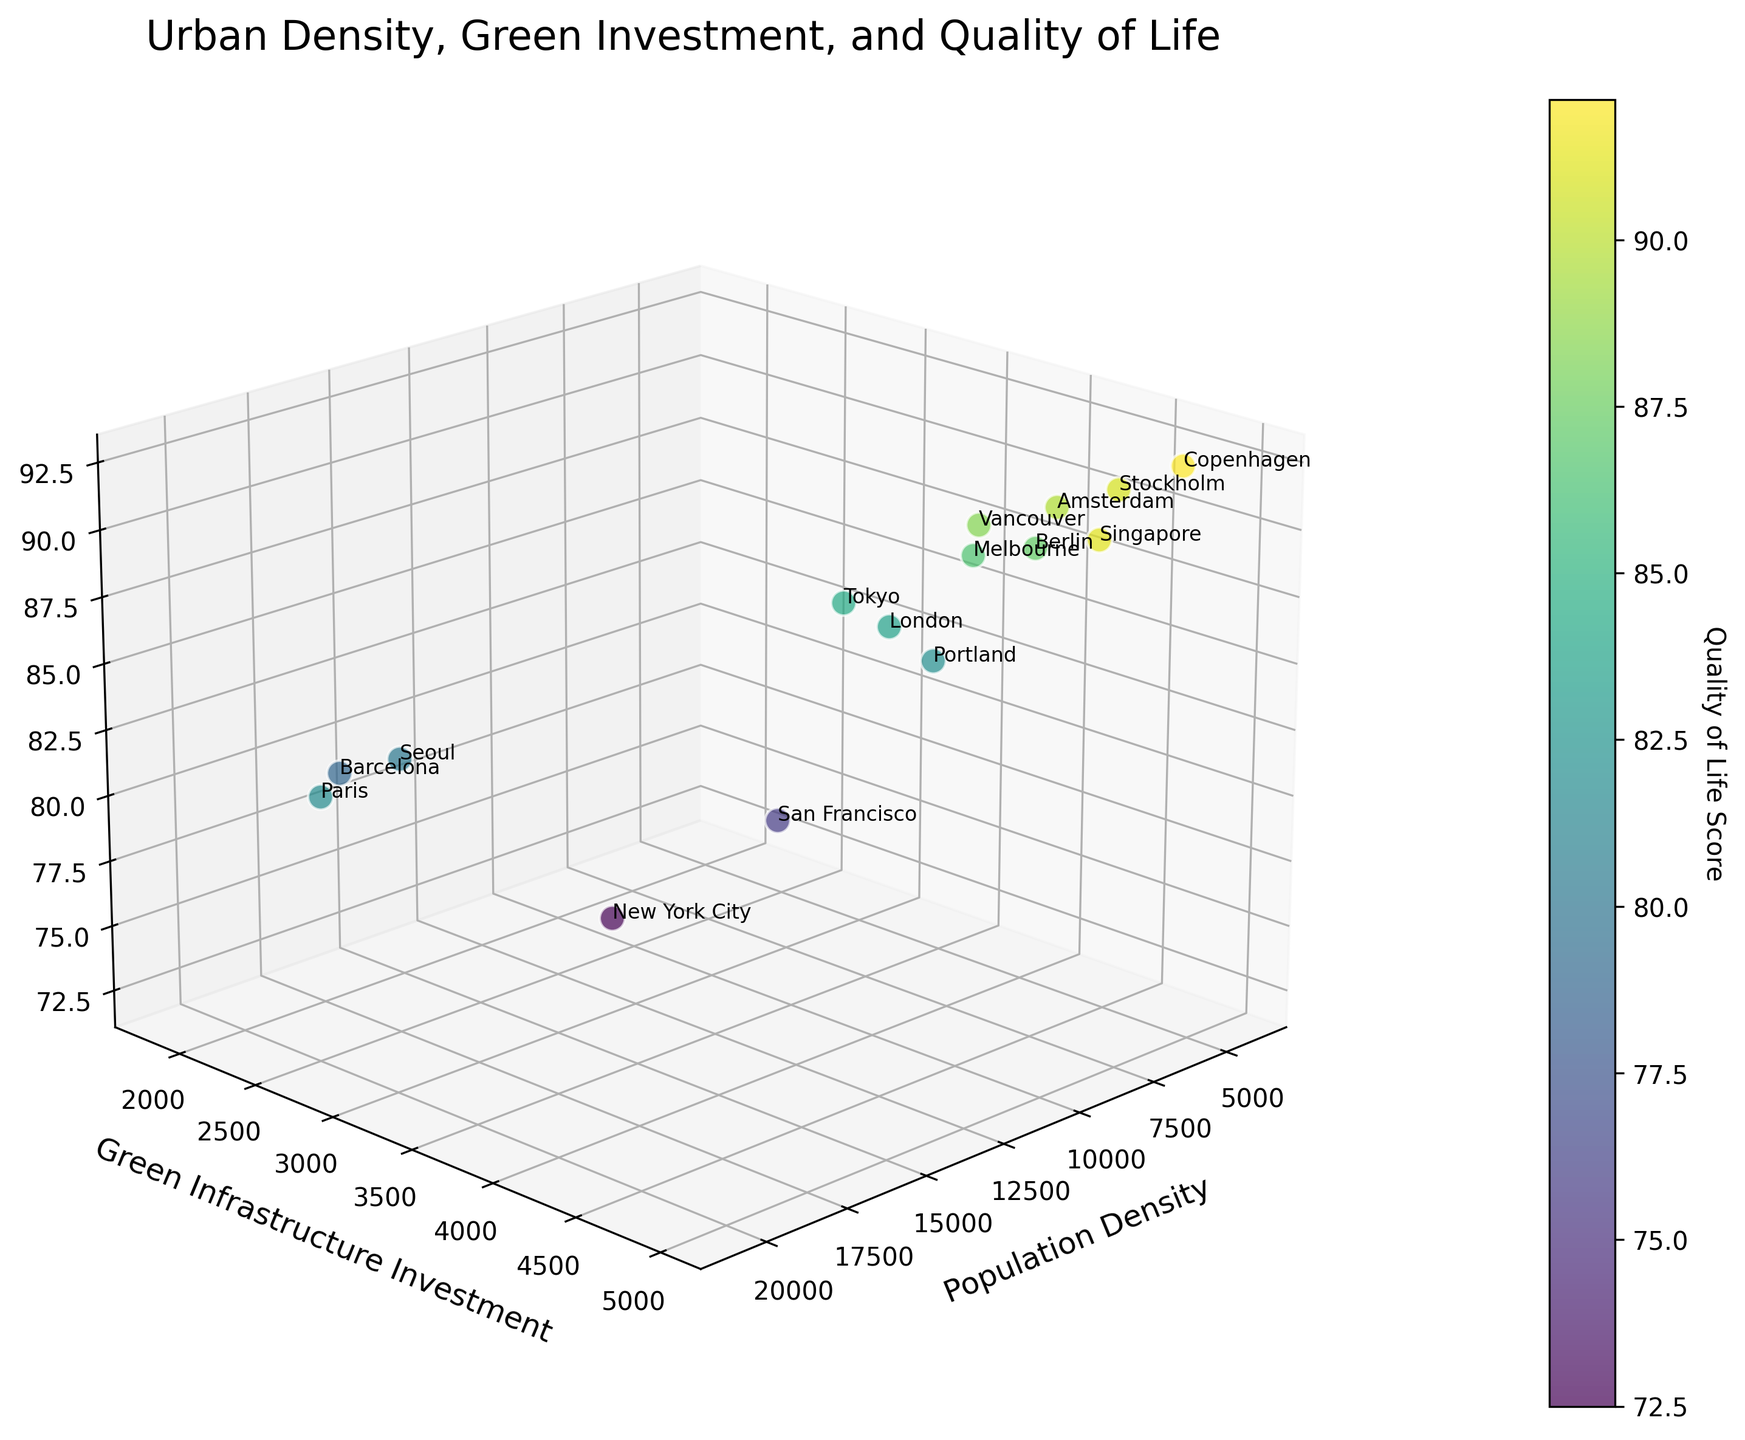what is the title of the plot? The title of the plot is written at the top of the figure. It reads 'Urban Density, Green Investment, and Quality of Life'.
Answer: Urban Density, Green Investment, and Quality of Life How many data points are plotted in the figure? Each city corresponds to a single data point on the scatter plot. By counting them, there are 15 cities shown.
Answer: 15 Which city has the highest Quality of Life Score? By looking at the third axis (Quality of Life Score) and identifying the topmost point with its label, Copenhagen has the highest score of 92.1.
Answer: Copenhagen Which city has the lowest Green Infrastructure Investment? By looking at the second axis (Green Infrastructure Investment) and identifying the leftmost point with its label, Barcelona has the lowest investment of 1800.
Answer: Barcelona What is the relationship between Population Density and Quality of Life Score for Paris? Paris has a high Population Density of 20781 and a Quality of Life Score of 81.9. Both values can be located in the 3D space by identifying the dense cluster on the x-axis and matching it to its corresponding value on the z-axis.
Answer: Paris has high population density and a moderately high quality of life score Which city has the highest Population Density? By looking at the first axis (Population Density) and identifying the rightmost point with its label, Paris has the highest density of 20781.
Answer: Paris How does Green Infrastructure Investment correlate with Quality of Life Score among the cities? By observing the spread and general trend of the data points as Green Infrastructure Investment increases along the y-axis, it generally corresponds to higher Quality of Life Scores along the z-axis. The trend is upward sloping.
Answer: More Green Infrastructure Investment generally leads to higher Quality of Life Scores Which city has the highest Quality of Life Score among cities with Population Density less than 5000? By first identifying the cities where Population Density is less than 5000 (Copenhagen, Melbourne, Berlin, Stockholm, and Portland) and then comparing their Quality of Life Scores, Copenhagen has the highest score of 92.1.
Answer: Copenhagen Which city with Green Infrastructure Investment above 4000 has the lowest Population Density? By first identifying the cities with Green Infrastructure Investment above 4000 (Amsterdam, Singapore, Copenhagen, and Stockholm) and then comparing their Population Densities, Copenhagen has the lowest density of 4400.
Answer: Copenhagen 